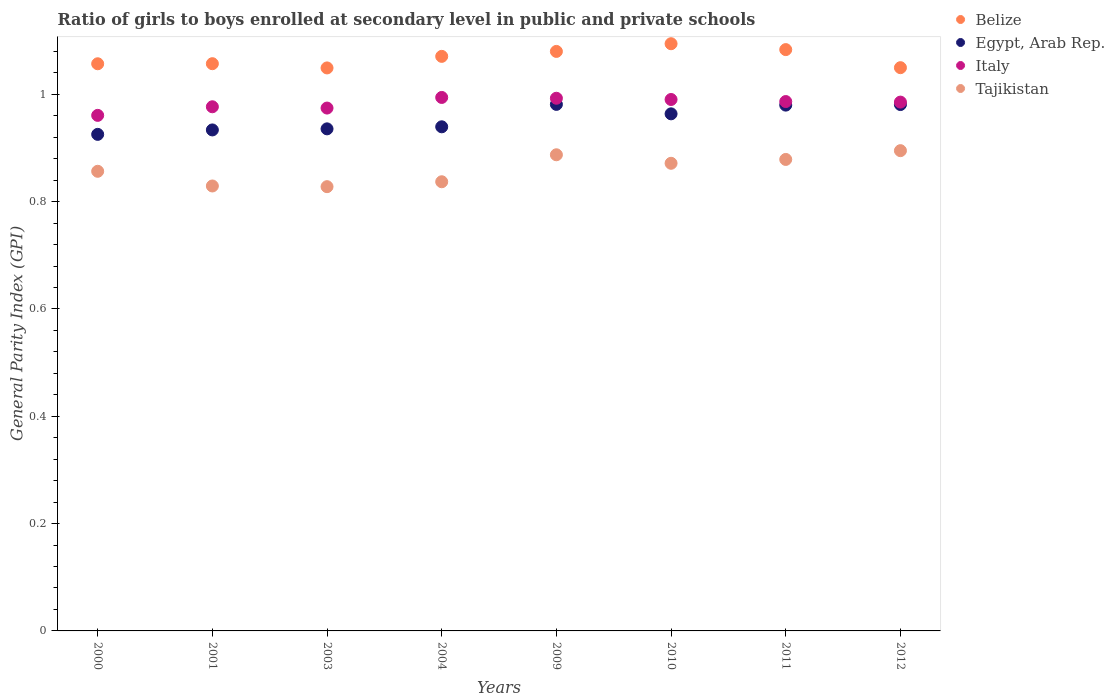Is the number of dotlines equal to the number of legend labels?
Provide a succinct answer. Yes. What is the general parity index in Italy in 2001?
Your answer should be compact. 0.98. Across all years, what is the maximum general parity index in Italy?
Ensure brevity in your answer.  0.99. Across all years, what is the minimum general parity index in Tajikistan?
Give a very brief answer. 0.83. In which year was the general parity index in Egypt, Arab Rep. maximum?
Provide a short and direct response. 2009. What is the total general parity index in Tajikistan in the graph?
Give a very brief answer. 6.88. What is the difference between the general parity index in Belize in 2011 and that in 2012?
Ensure brevity in your answer.  0.03. What is the difference between the general parity index in Egypt, Arab Rep. in 2011 and the general parity index in Tajikistan in 2003?
Offer a very short reply. 0.15. What is the average general parity index in Italy per year?
Your response must be concise. 0.98. In the year 2001, what is the difference between the general parity index in Tajikistan and general parity index in Egypt, Arab Rep.?
Give a very brief answer. -0.1. In how many years, is the general parity index in Tajikistan greater than 0.8?
Give a very brief answer. 8. What is the ratio of the general parity index in Tajikistan in 2009 to that in 2011?
Offer a very short reply. 1.01. What is the difference between the highest and the second highest general parity index in Tajikistan?
Offer a very short reply. 0.01. What is the difference between the highest and the lowest general parity index in Italy?
Make the answer very short. 0.03. In how many years, is the general parity index in Belize greater than the average general parity index in Belize taken over all years?
Offer a terse response. 4. Is the sum of the general parity index in Tajikistan in 2003 and 2012 greater than the maximum general parity index in Egypt, Arab Rep. across all years?
Keep it short and to the point. Yes. Is it the case that in every year, the sum of the general parity index in Tajikistan and general parity index in Italy  is greater than the general parity index in Belize?
Your answer should be compact. Yes. Does the general parity index in Egypt, Arab Rep. monotonically increase over the years?
Offer a very short reply. No. Is the general parity index in Tajikistan strictly greater than the general parity index in Egypt, Arab Rep. over the years?
Your response must be concise. No. How many dotlines are there?
Give a very brief answer. 4. How many years are there in the graph?
Ensure brevity in your answer.  8. What is the difference between two consecutive major ticks on the Y-axis?
Your answer should be compact. 0.2. Where does the legend appear in the graph?
Give a very brief answer. Top right. How are the legend labels stacked?
Your answer should be very brief. Vertical. What is the title of the graph?
Provide a succinct answer. Ratio of girls to boys enrolled at secondary level in public and private schools. Does "High income" appear as one of the legend labels in the graph?
Your answer should be very brief. No. What is the label or title of the Y-axis?
Offer a very short reply. General Parity Index (GPI). What is the General Parity Index (GPI) in Belize in 2000?
Your answer should be very brief. 1.06. What is the General Parity Index (GPI) of Egypt, Arab Rep. in 2000?
Provide a succinct answer. 0.93. What is the General Parity Index (GPI) of Italy in 2000?
Keep it short and to the point. 0.96. What is the General Parity Index (GPI) in Tajikistan in 2000?
Offer a terse response. 0.86. What is the General Parity Index (GPI) of Belize in 2001?
Offer a terse response. 1.06. What is the General Parity Index (GPI) of Egypt, Arab Rep. in 2001?
Provide a short and direct response. 0.93. What is the General Parity Index (GPI) in Italy in 2001?
Offer a terse response. 0.98. What is the General Parity Index (GPI) of Tajikistan in 2001?
Offer a very short reply. 0.83. What is the General Parity Index (GPI) of Belize in 2003?
Offer a very short reply. 1.05. What is the General Parity Index (GPI) in Egypt, Arab Rep. in 2003?
Provide a succinct answer. 0.94. What is the General Parity Index (GPI) of Italy in 2003?
Keep it short and to the point. 0.97. What is the General Parity Index (GPI) of Tajikistan in 2003?
Offer a very short reply. 0.83. What is the General Parity Index (GPI) of Belize in 2004?
Your answer should be compact. 1.07. What is the General Parity Index (GPI) in Egypt, Arab Rep. in 2004?
Make the answer very short. 0.94. What is the General Parity Index (GPI) in Italy in 2004?
Offer a terse response. 0.99. What is the General Parity Index (GPI) of Tajikistan in 2004?
Give a very brief answer. 0.84. What is the General Parity Index (GPI) of Belize in 2009?
Keep it short and to the point. 1.08. What is the General Parity Index (GPI) of Egypt, Arab Rep. in 2009?
Give a very brief answer. 0.98. What is the General Parity Index (GPI) of Italy in 2009?
Provide a succinct answer. 0.99. What is the General Parity Index (GPI) of Tajikistan in 2009?
Offer a very short reply. 0.89. What is the General Parity Index (GPI) of Belize in 2010?
Make the answer very short. 1.09. What is the General Parity Index (GPI) in Egypt, Arab Rep. in 2010?
Your answer should be compact. 0.96. What is the General Parity Index (GPI) in Italy in 2010?
Your answer should be very brief. 0.99. What is the General Parity Index (GPI) in Tajikistan in 2010?
Provide a succinct answer. 0.87. What is the General Parity Index (GPI) of Belize in 2011?
Keep it short and to the point. 1.08. What is the General Parity Index (GPI) in Egypt, Arab Rep. in 2011?
Offer a very short reply. 0.98. What is the General Parity Index (GPI) in Italy in 2011?
Your response must be concise. 0.99. What is the General Parity Index (GPI) in Tajikistan in 2011?
Your response must be concise. 0.88. What is the General Parity Index (GPI) in Belize in 2012?
Ensure brevity in your answer.  1.05. What is the General Parity Index (GPI) of Egypt, Arab Rep. in 2012?
Offer a very short reply. 0.98. What is the General Parity Index (GPI) of Italy in 2012?
Provide a short and direct response. 0.99. What is the General Parity Index (GPI) in Tajikistan in 2012?
Your answer should be compact. 0.9. Across all years, what is the maximum General Parity Index (GPI) in Belize?
Your answer should be very brief. 1.09. Across all years, what is the maximum General Parity Index (GPI) in Egypt, Arab Rep.?
Make the answer very short. 0.98. Across all years, what is the maximum General Parity Index (GPI) of Italy?
Keep it short and to the point. 0.99. Across all years, what is the maximum General Parity Index (GPI) of Tajikistan?
Offer a terse response. 0.9. Across all years, what is the minimum General Parity Index (GPI) in Belize?
Your answer should be very brief. 1.05. Across all years, what is the minimum General Parity Index (GPI) of Egypt, Arab Rep.?
Give a very brief answer. 0.93. Across all years, what is the minimum General Parity Index (GPI) in Italy?
Your answer should be compact. 0.96. Across all years, what is the minimum General Parity Index (GPI) of Tajikistan?
Keep it short and to the point. 0.83. What is the total General Parity Index (GPI) of Belize in the graph?
Your answer should be compact. 8.54. What is the total General Parity Index (GPI) in Egypt, Arab Rep. in the graph?
Offer a very short reply. 7.64. What is the total General Parity Index (GPI) of Italy in the graph?
Your answer should be very brief. 7.86. What is the total General Parity Index (GPI) in Tajikistan in the graph?
Ensure brevity in your answer.  6.88. What is the difference between the General Parity Index (GPI) of Belize in 2000 and that in 2001?
Make the answer very short. -0. What is the difference between the General Parity Index (GPI) of Egypt, Arab Rep. in 2000 and that in 2001?
Ensure brevity in your answer.  -0.01. What is the difference between the General Parity Index (GPI) of Italy in 2000 and that in 2001?
Provide a short and direct response. -0.02. What is the difference between the General Parity Index (GPI) of Tajikistan in 2000 and that in 2001?
Your answer should be very brief. 0.03. What is the difference between the General Parity Index (GPI) of Belize in 2000 and that in 2003?
Your answer should be very brief. 0.01. What is the difference between the General Parity Index (GPI) in Egypt, Arab Rep. in 2000 and that in 2003?
Ensure brevity in your answer.  -0.01. What is the difference between the General Parity Index (GPI) of Italy in 2000 and that in 2003?
Provide a succinct answer. -0.01. What is the difference between the General Parity Index (GPI) in Tajikistan in 2000 and that in 2003?
Ensure brevity in your answer.  0.03. What is the difference between the General Parity Index (GPI) of Belize in 2000 and that in 2004?
Your answer should be very brief. -0.01. What is the difference between the General Parity Index (GPI) of Egypt, Arab Rep. in 2000 and that in 2004?
Your answer should be compact. -0.01. What is the difference between the General Parity Index (GPI) of Italy in 2000 and that in 2004?
Offer a very short reply. -0.03. What is the difference between the General Parity Index (GPI) in Tajikistan in 2000 and that in 2004?
Give a very brief answer. 0.02. What is the difference between the General Parity Index (GPI) of Belize in 2000 and that in 2009?
Your answer should be very brief. -0.02. What is the difference between the General Parity Index (GPI) in Egypt, Arab Rep. in 2000 and that in 2009?
Give a very brief answer. -0.06. What is the difference between the General Parity Index (GPI) in Italy in 2000 and that in 2009?
Offer a terse response. -0.03. What is the difference between the General Parity Index (GPI) in Tajikistan in 2000 and that in 2009?
Offer a very short reply. -0.03. What is the difference between the General Parity Index (GPI) in Belize in 2000 and that in 2010?
Give a very brief answer. -0.04. What is the difference between the General Parity Index (GPI) in Egypt, Arab Rep. in 2000 and that in 2010?
Offer a very short reply. -0.04. What is the difference between the General Parity Index (GPI) in Italy in 2000 and that in 2010?
Give a very brief answer. -0.03. What is the difference between the General Parity Index (GPI) in Tajikistan in 2000 and that in 2010?
Provide a short and direct response. -0.01. What is the difference between the General Parity Index (GPI) of Belize in 2000 and that in 2011?
Offer a terse response. -0.03. What is the difference between the General Parity Index (GPI) in Egypt, Arab Rep. in 2000 and that in 2011?
Give a very brief answer. -0.05. What is the difference between the General Parity Index (GPI) of Italy in 2000 and that in 2011?
Provide a succinct answer. -0.03. What is the difference between the General Parity Index (GPI) in Tajikistan in 2000 and that in 2011?
Ensure brevity in your answer.  -0.02. What is the difference between the General Parity Index (GPI) in Belize in 2000 and that in 2012?
Keep it short and to the point. 0.01. What is the difference between the General Parity Index (GPI) in Egypt, Arab Rep. in 2000 and that in 2012?
Offer a very short reply. -0.06. What is the difference between the General Parity Index (GPI) of Italy in 2000 and that in 2012?
Your answer should be very brief. -0.02. What is the difference between the General Parity Index (GPI) of Tajikistan in 2000 and that in 2012?
Make the answer very short. -0.04. What is the difference between the General Parity Index (GPI) in Belize in 2001 and that in 2003?
Keep it short and to the point. 0.01. What is the difference between the General Parity Index (GPI) in Egypt, Arab Rep. in 2001 and that in 2003?
Your answer should be compact. -0. What is the difference between the General Parity Index (GPI) of Italy in 2001 and that in 2003?
Make the answer very short. 0. What is the difference between the General Parity Index (GPI) in Tajikistan in 2001 and that in 2003?
Ensure brevity in your answer.  0. What is the difference between the General Parity Index (GPI) of Belize in 2001 and that in 2004?
Keep it short and to the point. -0.01. What is the difference between the General Parity Index (GPI) in Egypt, Arab Rep. in 2001 and that in 2004?
Keep it short and to the point. -0.01. What is the difference between the General Parity Index (GPI) of Italy in 2001 and that in 2004?
Make the answer very short. -0.02. What is the difference between the General Parity Index (GPI) in Tajikistan in 2001 and that in 2004?
Your response must be concise. -0.01. What is the difference between the General Parity Index (GPI) in Belize in 2001 and that in 2009?
Offer a very short reply. -0.02. What is the difference between the General Parity Index (GPI) in Egypt, Arab Rep. in 2001 and that in 2009?
Your response must be concise. -0.05. What is the difference between the General Parity Index (GPI) of Italy in 2001 and that in 2009?
Ensure brevity in your answer.  -0.02. What is the difference between the General Parity Index (GPI) of Tajikistan in 2001 and that in 2009?
Provide a succinct answer. -0.06. What is the difference between the General Parity Index (GPI) of Belize in 2001 and that in 2010?
Your response must be concise. -0.04. What is the difference between the General Parity Index (GPI) in Egypt, Arab Rep. in 2001 and that in 2010?
Ensure brevity in your answer.  -0.03. What is the difference between the General Parity Index (GPI) in Italy in 2001 and that in 2010?
Ensure brevity in your answer.  -0.01. What is the difference between the General Parity Index (GPI) in Tajikistan in 2001 and that in 2010?
Your answer should be compact. -0.04. What is the difference between the General Parity Index (GPI) in Belize in 2001 and that in 2011?
Ensure brevity in your answer.  -0.03. What is the difference between the General Parity Index (GPI) in Egypt, Arab Rep. in 2001 and that in 2011?
Offer a very short reply. -0.05. What is the difference between the General Parity Index (GPI) in Italy in 2001 and that in 2011?
Your response must be concise. -0.01. What is the difference between the General Parity Index (GPI) in Tajikistan in 2001 and that in 2011?
Ensure brevity in your answer.  -0.05. What is the difference between the General Parity Index (GPI) in Belize in 2001 and that in 2012?
Your answer should be compact. 0.01. What is the difference between the General Parity Index (GPI) of Egypt, Arab Rep. in 2001 and that in 2012?
Give a very brief answer. -0.05. What is the difference between the General Parity Index (GPI) of Italy in 2001 and that in 2012?
Keep it short and to the point. -0.01. What is the difference between the General Parity Index (GPI) in Tajikistan in 2001 and that in 2012?
Your response must be concise. -0.07. What is the difference between the General Parity Index (GPI) in Belize in 2003 and that in 2004?
Ensure brevity in your answer.  -0.02. What is the difference between the General Parity Index (GPI) of Egypt, Arab Rep. in 2003 and that in 2004?
Offer a very short reply. -0. What is the difference between the General Parity Index (GPI) in Italy in 2003 and that in 2004?
Ensure brevity in your answer.  -0.02. What is the difference between the General Parity Index (GPI) of Tajikistan in 2003 and that in 2004?
Keep it short and to the point. -0.01. What is the difference between the General Parity Index (GPI) in Belize in 2003 and that in 2009?
Ensure brevity in your answer.  -0.03. What is the difference between the General Parity Index (GPI) in Egypt, Arab Rep. in 2003 and that in 2009?
Ensure brevity in your answer.  -0.05. What is the difference between the General Parity Index (GPI) of Italy in 2003 and that in 2009?
Ensure brevity in your answer.  -0.02. What is the difference between the General Parity Index (GPI) in Tajikistan in 2003 and that in 2009?
Your answer should be compact. -0.06. What is the difference between the General Parity Index (GPI) in Belize in 2003 and that in 2010?
Ensure brevity in your answer.  -0.05. What is the difference between the General Parity Index (GPI) of Egypt, Arab Rep. in 2003 and that in 2010?
Give a very brief answer. -0.03. What is the difference between the General Parity Index (GPI) in Italy in 2003 and that in 2010?
Keep it short and to the point. -0.02. What is the difference between the General Parity Index (GPI) in Tajikistan in 2003 and that in 2010?
Offer a terse response. -0.04. What is the difference between the General Parity Index (GPI) of Belize in 2003 and that in 2011?
Make the answer very short. -0.03. What is the difference between the General Parity Index (GPI) of Egypt, Arab Rep. in 2003 and that in 2011?
Offer a terse response. -0.04. What is the difference between the General Parity Index (GPI) of Italy in 2003 and that in 2011?
Your answer should be compact. -0.01. What is the difference between the General Parity Index (GPI) in Tajikistan in 2003 and that in 2011?
Your answer should be very brief. -0.05. What is the difference between the General Parity Index (GPI) in Belize in 2003 and that in 2012?
Your answer should be very brief. -0. What is the difference between the General Parity Index (GPI) in Egypt, Arab Rep. in 2003 and that in 2012?
Keep it short and to the point. -0.05. What is the difference between the General Parity Index (GPI) of Italy in 2003 and that in 2012?
Your answer should be compact. -0.01. What is the difference between the General Parity Index (GPI) of Tajikistan in 2003 and that in 2012?
Ensure brevity in your answer.  -0.07. What is the difference between the General Parity Index (GPI) of Belize in 2004 and that in 2009?
Offer a terse response. -0.01. What is the difference between the General Parity Index (GPI) in Egypt, Arab Rep. in 2004 and that in 2009?
Make the answer very short. -0.04. What is the difference between the General Parity Index (GPI) of Italy in 2004 and that in 2009?
Keep it short and to the point. 0. What is the difference between the General Parity Index (GPI) in Tajikistan in 2004 and that in 2009?
Make the answer very short. -0.05. What is the difference between the General Parity Index (GPI) of Belize in 2004 and that in 2010?
Provide a short and direct response. -0.02. What is the difference between the General Parity Index (GPI) in Egypt, Arab Rep. in 2004 and that in 2010?
Offer a very short reply. -0.02. What is the difference between the General Parity Index (GPI) in Italy in 2004 and that in 2010?
Keep it short and to the point. 0. What is the difference between the General Parity Index (GPI) of Tajikistan in 2004 and that in 2010?
Ensure brevity in your answer.  -0.03. What is the difference between the General Parity Index (GPI) of Belize in 2004 and that in 2011?
Give a very brief answer. -0.01. What is the difference between the General Parity Index (GPI) of Egypt, Arab Rep. in 2004 and that in 2011?
Your answer should be very brief. -0.04. What is the difference between the General Parity Index (GPI) in Italy in 2004 and that in 2011?
Provide a succinct answer. 0.01. What is the difference between the General Parity Index (GPI) in Tajikistan in 2004 and that in 2011?
Your response must be concise. -0.04. What is the difference between the General Parity Index (GPI) in Belize in 2004 and that in 2012?
Ensure brevity in your answer.  0.02. What is the difference between the General Parity Index (GPI) of Egypt, Arab Rep. in 2004 and that in 2012?
Provide a succinct answer. -0.04. What is the difference between the General Parity Index (GPI) in Italy in 2004 and that in 2012?
Give a very brief answer. 0.01. What is the difference between the General Parity Index (GPI) of Tajikistan in 2004 and that in 2012?
Keep it short and to the point. -0.06. What is the difference between the General Parity Index (GPI) in Belize in 2009 and that in 2010?
Make the answer very short. -0.01. What is the difference between the General Parity Index (GPI) in Egypt, Arab Rep. in 2009 and that in 2010?
Give a very brief answer. 0.02. What is the difference between the General Parity Index (GPI) of Italy in 2009 and that in 2010?
Provide a short and direct response. 0. What is the difference between the General Parity Index (GPI) of Tajikistan in 2009 and that in 2010?
Make the answer very short. 0.02. What is the difference between the General Parity Index (GPI) in Belize in 2009 and that in 2011?
Give a very brief answer. -0. What is the difference between the General Parity Index (GPI) in Egypt, Arab Rep. in 2009 and that in 2011?
Offer a very short reply. 0. What is the difference between the General Parity Index (GPI) of Italy in 2009 and that in 2011?
Offer a very short reply. 0.01. What is the difference between the General Parity Index (GPI) in Tajikistan in 2009 and that in 2011?
Offer a very short reply. 0.01. What is the difference between the General Parity Index (GPI) in Belize in 2009 and that in 2012?
Your answer should be compact. 0.03. What is the difference between the General Parity Index (GPI) in Egypt, Arab Rep. in 2009 and that in 2012?
Your answer should be very brief. 0. What is the difference between the General Parity Index (GPI) in Italy in 2009 and that in 2012?
Provide a short and direct response. 0.01. What is the difference between the General Parity Index (GPI) of Tajikistan in 2009 and that in 2012?
Make the answer very short. -0.01. What is the difference between the General Parity Index (GPI) in Belize in 2010 and that in 2011?
Offer a terse response. 0.01. What is the difference between the General Parity Index (GPI) in Egypt, Arab Rep. in 2010 and that in 2011?
Give a very brief answer. -0.02. What is the difference between the General Parity Index (GPI) in Italy in 2010 and that in 2011?
Make the answer very short. 0. What is the difference between the General Parity Index (GPI) in Tajikistan in 2010 and that in 2011?
Give a very brief answer. -0.01. What is the difference between the General Parity Index (GPI) in Belize in 2010 and that in 2012?
Ensure brevity in your answer.  0.04. What is the difference between the General Parity Index (GPI) in Egypt, Arab Rep. in 2010 and that in 2012?
Your answer should be compact. -0.02. What is the difference between the General Parity Index (GPI) in Italy in 2010 and that in 2012?
Keep it short and to the point. 0. What is the difference between the General Parity Index (GPI) of Tajikistan in 2010 and that in 2012?
Make the answer very short. -0.02. What is the difference between the General Parity Index (GPI) in Belize in 2011 and that in 2012?
Offer a terse response. 0.03. What is the difference between the General Parity Index (GPI) of Egypt, Arab Rep. in 2011 and that in 2012?
Your answer should be very brief. -0. What is the difference between the General Parity Index (GPI) in Tajikistan in 2011 and that in 2012?
Give a very brief answer. -0.02. What is the difference between the General Parity Index (GPI) of Belize in 2000 and the General Parity Index (GPI) of Egypt, Arab Rep. in 2001?
Keep it short and to the point. 0.12. What is the difference between the General Parity Index (GPI) in Belize in 2000 and the General Parity Index (GPI) in Italy in 2001?
Offer a terse response. 0.08. What is the difference between the General Parity Index (GPI) of Belize in 2000 and the General Parity Index (GPI) of Tajikistan in 2001?
Provide a short and direct response. 0.23. What is the difference between the General Parity Index (GPI) in Egypt, Arab Rep. in 2000 and the General Parity Index (GPI) in Italy in 2001?
Give a very brief answer. -0.05. What is the difference between the General Parity Index (GPI) in Egypt, Arab Rep. in 2000 and the General Parity Index (GPI) in Tajikistan in 2001?
Your response must be concise. 0.1. What is the difference between the General Parity Index (GPI) of Italy in 2000 and the General Parity Index (GPI) of Tajikistan in 2001?
Offer a very short reply. 0.13. What is the difference between the General Parity Index (GPI) of Belize in 2000 and the General Parity Index (GPI) of Egypt, Arab Rep. in 2003?
Provide a succinct answer. 0.12. What is the difference between the General Parity Index (GPI) of Belize in 2000 and the General Parity Index (GPI) of Italy in 2003?
Ensure brevity in your answer.  0.08. What is the difference between the General Parity Index (GPI) in Belize in 2000 and the General Parity Index (GPI) in Tajikistan in 2003?
Your answer should be very brief. 0.23. What is the difference between the General Parity Index (GPI) in Egypt, Arab Rep. in 2000 and the General Parity Index (GPI) in Italy in 2003?
Offer a very short reply. -0.05. What is the difference between the General Parity Index (GPI) in Egypt, Arab Rep. in 2000 and the General Parity Index (GPI) in Tajikistan in 2003?
Your response must be concise. 0.1. What is the difference between the General Parity Index (GPI) of Italy in 2000 and the General Parity Index (GPI) of Tajikistan in 2003?
Your answer should be very brief. 0.13. What is the difference between the General Parity Index (GPI) of Belize in 2000 and the General Parity Index (GPI) of Egypt, Arab Rep. in 2004?
Give a very brief answer. 0.12. What is the difference between the General Parity Index (GPI) in Belize in 2000 and the General Parity Index (GPI) in Italy in 2004?
Keep it short and to the point. 0.06. What is the difference between the General Parity Index (GPI) in Belize in 2000 and the General Parity Index (GPI) in Tajikistan in 2004?
Provide a short and direct response. 0.22. What is the difference between the General Parity Index (GPI) of Egypt, Arab Rep. in 2000 and the General Parity Index (GPI) of Italy in 2004?
Give a very brief answer. -0.07. What is the difference between the General Parity Index (GPI) in Egypt, Arab Rep. in 2000 and the General Parity Index (GPI) in Tajikistan in 2004?
Your response must be concise. 0.09. What is the difference between the General Parity Index (GPI) in Italy in 2000 and the General Parity Index (GPI) in Tajikistan in 2004?
Offer a very short reply. 0.12. What is the difference between the General Parity Index (GPI) of Belize in 2000 and the General Parity Index (GPI) of Egypt, Arab Rep. in 2009?
Provide a short and direct response. 0.08. What is the difference between the General Parity Index (GPI) of Belize in 2000 and the General Parity Index (GPI) of Italy in 2009?
Keep it short and to the point. 0.06. What is the difference between the General Parity Index (GPI) of Belize in 2000 and the General Parity Index (GPI) of Tajikistan in 2009?
Your answer should be very brief. 0.17. What is the difference between the General Parity Index (GPI) in Egypt, Arab Rep. in 2000 and the General Parity Index (GPI) in Italy in 2009?
Provide a succinct answer. -0.07. What is the difference between the General Parity Index (GPI) of Egypt, Arab Rep. in 2000 and the General Parity Index (GPI) of Tajikistan in 2009?
Provide a succinct answer. 0.04. What is the difference between the General Parity Index (GPI) of Italy in 2000 and the General Parity Index (GPI) of Tajikistan in 2009?
Keep it short and to the point. 0.07. What is the difference between the General Parity Index (GPI) of Belize in 2000 and the General Parity Index (GPI) of Egypt, Arab Rep. in 2010?
Provide a succinct answer. 0.09. What is the difference between the General Parity Index (GPI) of Belize in 2000 and the General Parity Index (GPI) of Italy in 2010?
Ensure brevity in your answer.  0.07. What is the difference between the General Parity Index (GPI) in Belize in 2000 and the General Parity Index (GPI) in Tajikistan in 2010?
Offer a terse response. 0.19. What is the difference between the General Parity Index (GPI) in Egypt, Arab Rep. in 2000 and the General Parity Index (GPI) in Italy in 2010?
Provide a succinct answer. -0.07. What is the difference between the General Parity Index (GPI) of Egypt, Arab Rep. in 2000 and the General Parity Index (GPI) of Tajikistan in 2010?
Provide a succinct answer. 0.05. What is the difference between the General Parity Index (GPI) in Italy in 2000 and the General Parity Index (GPI) in Tajikistan in 2010?
Provide a short and direct response. 0.09. What is the difference between the General Parity Index (GPI) in Belize in 2000 and the General Parity Index (GPI) in Egypt, Arab Rep. in 2011?
Make the answer very short. 0.08. What is the difference between the General Parity Index (GPI) of Belize in 2000 and the General Parity Index (GPI) of Italy in 2011?
Your answer should be very brief. 0.07. What is the difference between the General Parity Index (GPI) of Belize in 2000 and the General Parity Index (GPI) of Tajikistan in 2011?
Give a very brief answer. 0.18. What is the difference between the General Parity Index (GPI) of Egypt, Arab Rep. in 2000 and the General Parity Index (GPI) of Italy in 2011?
Make the answer very short. -0.06. What is the difference between the General Parity Index (GPI) in Egypt, Arab Rep. in 2000 and the General Parity Index (GPI) in Tajikistan in 2011?
Your response must be concise. 0.05. What is the difference between the General Parity Index (GPI) in Italy in 2000 and the General Parity Index (GPI) in Tajikistan in 2011?
Offer a terse response. 0.08. What is the difference between the General Parity Index (GPI) of Belize in 2000 and the General Parity Index (GPI) of Egypt, Arab Rep. in 2012?
Give a very brief answer. 0.08. What is the difference between the General Parity Index (GPI) in Belize in 2000 and the General Parity Index (GPI) in Italy in 2012?
Offer a terse response. 0.07. What is the difference between the General Parity Index (GPI) in Belize in 2000 and the General Parity Index (GPI) in Tajikistan in 2012?
Your response must be concise. 0.16. What is the difference between the General Parity Index (GPI) in Egypt, Arab Rep. in 2000 and the General Parity Index (GPI) in Italy in 2012?
Offer a very short reply. -0.06. What is the difference between the General Parity Index (GPI) in Egypt, Arab Rep. in 2000 and the General Parity Index (GPI) in Tajikistan in 2012?
Make the answer very short. 0.03. What is the difference between the General Parity Index (GPI) in Italy in 2000 and the General Parity Index (GPI) in Tajikistan in 2012?
Offer a very short reply. 0.07. What is the difference between the General Parity Index (GPI) in Belize in 2001 and the General Parity Index (GPI) in Egypt, Arab Rep. in 2003?
Ensure brevity in your answer.  0.12. What is the difference between the General Parity Index (GPI) of Belize in 2001 and the General Parity Index (GPI) of Italy in 2003?
Offer a very short reply. 0.08. What is the difference between the General Parity Index (GPI) of Belize in 2001 and the General Parity Index (GPI) of Tajikistan in 2003?
Ensure brevity in your answer.  0.23. What is the difference between the General Parity Index (GPI) of Egypt, Arab Rep. in 2001 and the General Parity Index (GPI) of Italy in 2003?
Offer a terse response. -0.04. What is the difference between the General Parity Index (GPI) of Egypt, Arab Rep. in 2001 and the General Parity Index (GPI) of Tajikistan in 2003?
Offer a very short reply. 0.11. What is the difference between the General Parity Index (GPI) of Italy in 2001 and the General Parity Index (GPI) of Tajikistan in 2003?
Ensure brevity in your answer.  0.15. What is the difference between the General Parity Index (GPI) of Belize in 2001 and the General Parity Index (GPI) of Egypt, Arab Rep. in 2004?
Provide a succinct answer. 0.12. What is the difference between the General Parity Index (GPI) of Belize in 2001 and the General Parity Index (GPI) of Italy in 2004?
Ensure brevity in your answer.  0.06. What is the difference between the General Parity Index (GPI) in Belize in 2001 and the General Parity Index (GPI) in Tajikistan in 2004?
Give a very brief answer. 0.22. What is the difference between the General Parity Index (GPI) of Egypt, Arab Rep. in 2001 and the General Parity Index (GPI) of Italy in 2004?
Offer a terse response. -0.06. What is the difference between the General Parity Index (GPI) in Egypt, Arab Rep. in 2001 and the General Parity Index (GPI) in Tajikistan in 2004?
Make the answer very short. 0.1. What is the difference between the General Parity Index (GPI) in Italy in 2001 and the General Parity Index (GPI) in Tajikistan in 2004?
Give a very brief answer. 0.14. What is the difference between the General Parity Index (GPI) in Belize in 2001 and the General Parity Index (GPI) in Egypt, Arab Rep. in 2009?
Your answer should be compact. 0.08. What is the difference between the General Parity Index (GPI) in Belize in 2001 and the General Parity Index (GPI) in Italy in 2009?
Offer a terse response. 0.06. What is the difference between the General Parity Index (GPI) of Belize in 2001 and the General Parity Index (GPI) of Tajikistan in 2009?
Keep it short and to the point. 0.17. What is the difference between the General Parity Index (GPI) of Egypt, Arab Rep. in 2001 and the General Parity Index (GPI) of Italy in 2009?
Your answer should be very brief. -0.06. What is the difference between the General Parity Index (GPI) in Egypt, Arab Rep. in 2001 and the General Parity Index (GPI) in Tajikistan in 2009?
Your response must be concise. 0.05. What is the difference between the General Parity Index (GPI) of Italy in 2001 and the General Parity Index (GPI) of Tajikistan in 2009?
Make the answer very short. 0.09. What is the difference between the General Parity Index (GPI) of Belize in 2001 and the General Parity Index (GPI) of Egypt, Arab Rep. in 2010?
Provide a short and direct response. 0.09. What is the difference between the General Parity Index (GPI) of Belize in 2001 and the General Parity Index (GPI) of Italy in 2010?
Make the answer very short. 0.07. What is the difference between the General Parity Index (GPI) in Belize in 2001 and the General Parity Index (GPI) in Tajikistan in 2010?
Give a very brief answer. 0.19. What is the difference between the General Parity Index (GPI) in Egypt, Arab Rep. in 2001 and the General Parity Index (GPI) in Italy in 2010?
Provide a succinct answer. -0.06. What is the difference between the General Parity Index (GPI) in Egypt, Arab Rep. in 2001 and the General Parity Index (GPI) in Tajikistan in 2010?
Provide a short and direct response. 0.06. What is the difference between the General Parity Index (GPI) of Italy in 2001 and the General Parity Index (GPI) of Tajikistan in 2010?
Provide a succinct answer. 0.11. What is the difference between the General Parity Index (GPI) in Belize in 2001 and the General Parity Index (GPI) in Egypt, Arab Rep. in 2011?
Your answer should be compact. 0.08. What is the difference between the General Parity Index (GPI) of Belize in 2001 and the General Parity Index (GPI) of Italy in 2011?
Your answer should be compact. 0.07. What is the difference between the General Parity Index (GPI) of Belize in 2001 and the General Parity Index (GPI) of Tajikistan in 2011?
Your answer should be very brief. 0.18. What is the difference between the General Parity Index (GPI) in Egypt, Arab Rep. in 2001 and the General Parity Index (GPI) in Italy in 2011?
Your response must be concise. -0.05. What is the difference between the General Parity Index (GPI) in Egypt, Arab Rep. in 2001 and the General Parity Index (GPI) in Tajikistan in 2011?
Keep it short and to the point. 0.06. What is the difference between the General Parity Index (GPI) of Italy in 2001 and the General Parity Index (GPI) of Tajikistan in 2011?
Provide a short and direct response. 0.1. What is the difference between the General Parity Index (GPI) in Belize in 2001 and the General Parity Index (GPI) in Egypt, Arab Rep. in 2012?
Keep it short and to the point. 0.08. What is the difference between the General Parity Index (GPI) in Belize in 2001 and the General Parity Index (GPI) in Italy in 2012?
Ensure brevity in your answer.  0.07. What is the difference between the General Parity Index (GPI) in Belize in 2001 and the General Parity Index (GPI) in Tajikistan in 2012?
Your answer should be compact. 0.16. What is the difference between the General Parity Index (GPI) in Egypt, Arab Rep. in 2001 and the General Parity Index (GPI) in Italy in 2012?
Your answer should be very brief. -0.05. What is the difference between the General Parity Index (GPI) of Egypt, Arab Rep. in 2001 and the General Parity Index (GPI) of Tajikistan in 2012?
Your response must be concise. 0.04. What is the difference between the General Parity Index (GPI) of Italy in 2001 and the General Parity Index (GPI) of Tajikistan in 2012?
Your answer should be compact. 0.08. What is the difference between the General Parity Index (GPI) in Belize in 2003 and the General Parity Index (GPI) in Egypt, Arab Rep. in 2004?
Offer a very short reply. 0.11. What is the difference between the General Parity Index (GPI) of Belize in 2003 and the General Parity Index (GPI) of Italy in 2004?
Make the answer very short. 0.06. What is the difference between the General Parity Index (GPI) of Belize in 2003 and the General Parity Index (GPI) of Tajikistan in 2004?
Ensure brevity in your answer.  0.21. What is the difference between the General Parity Index (GPI) of Egypt, Arab Rep. in 2003 and the General Parity Index (GPI) of Italy in 2004?
Provide a short and direct response. -0.06. What is the difference between the General Parity Index (GPI) in Egypt, Arab Rep. in 2003 and the General Parity Index (GPI) in Tajikistan in 2004?
Offer a very short reply. 0.1. What is the difference between the General Parity Index (GPI) of Italy in 2003 and the General Parity Index (GPI) of Tajikistan in 2004?
Offer a terse response. 0.14. What is the difference between the General Parity Index (GPI) of Belize in 2003 and the General Parity Index (GPI) of Egypt, Arab Rep. in 2009?
Your response must be concise. 0.07. What is the difference between the General Parity Index (GPI) of Belize in 2003 and the General Parity Index (GPI) of Italy in 2009?
Provide a short and direct response. 0.06. What is the difference between the General Parity Index (GPI) in Belize in 2003 and the General Parity Index (GPI) in Tajikistan in 2009?
Offer a terse response. 0.16. What is the difference between the General Parity Index (GPI) of Egypt, Arab Rep. in 2003 and the General Parity Index (GPI) of Italy in 2009?
Offer a terse response. -0.06. What is the difference between the General Parity Index (GPI) of Egypt, Arab Rep. in 2003 and the General Parity Index (GPI) of Tajikistan in 2009?
Give a very brief answer. 0.05. What is the difference between the General Parity Index (GPI) in Italy in 2003 and the General Parity Index (GPI) in Tajikistan in 2009?
Offer a terse response. 0.09. What is the difference between the General Parity Index (GPI) of Belize in 2003 and the General Parity Index (GPI) of Egypt, Arab Rep. in 2010?
Your response must be concise. 0.09. What is the difference between the General Parity Index (GPI) of Belize in 2003 and the General Parity Index (GPI) of Italy in 2010?
Your response must be concise. 0.06. What is the difference between the General Parity Index (GPI) in Belize in 2003 and the General Parity Index (GPI) in Tajikistan in 2010?
Keep it short and to the point. 0.18. What is the difference between the General Parity Index (GPI) of Egypt, Arab Rep. in 2003 and the General Parity Index (GPI) of Italy in 2010?
Give a very brief answer. -0.05. What is the difference between the General Parity Index (GPI) in Egypt, Arab Rep. in 2003 and the General Parity Index (GPI) in Tajikistan in 2010?
Provide a succinct answer. 0.06. What is the difference between the General Parity Index (GPI) in Italy in 2003 and the General Parity Index (GPI) in Tajikistan in 2010?
Provide a short and direct response. 0.1. What is the difference between the General Parity Index (GPI) of Belize in 2003 and the General Parity Index (GPI) of Egypt, Arab Rep. in 2011?
Make the answer very short. 0.07. What is the difference between the General Parity Index (GPI) of Belize in 2003 and the General Parity Index (GPI) of Italy in 2011?
Your answer should be compact. 0.06. What is the difference between the General Parity Index (GPI) of Belize in 2003 and the General Parity Index (GPI) of Tajikistan in 2011?
Ensure brevity in your answer.  0.17. What is the difference between the General Parity Index (GPI) of Egypt, Arab Rep. in 2003 and the General Parity Index (GPI) of Italy in 2011?
Give a very brief answer. -0.05. What is the difference between the General Parity Index (GPI) of Egypt, Arab Rep. in 2003 and the General Parity Index (GPI) of Tajikistan in 2011?
Keep it short and to the point. 0.06. What is the difference between the General Parity Index (GPI) in Italy in 2003 and the General Parity Index (GPI) in Tajikistan in 2011?
Your response must be concise. 0.1. What is the difference between the General Parity Index (GPI) of Belize in 2003 and the General Parity Index (GPI) of Egypt, Arab Rep. in 2012?
Offer a very short reply. 0.07. What is the difference between the General Parity Index (GPI) in Belize in 2003 and the General Parity Index (GPI) in Italy in 2012?
Your answer should be very brief. 0.06. What is the difference between the General Parity Index (GPI) of Belize in 2003 and the General Parity Index (GPI) of Tajikistan in 2012?
Provide a succinct answer. 0.15. What is the difference between the General Parity Index (GPI) of Egypt, Arab Rep. in 2003 and the General Parity Index (GPI) of Italy in 2012?
Give a very brief answer. -0.05. What is the difference between the General Parity Index (GPI) of Egypt, Arab Rep. in 2003 and the General Parity Index (GPI) of Tajikistan in 2012?
Make the answer very short. 0.04. What is the difference between the General Parity Index (GPI) of Italy in 2003 and the General Parity Index (GPI) of Tajikistan in 2012?
Give a very brief answer. 0.08. What is the difference between the General Parity Index (GPI) in Belize in 2004 and the General Parity Index (GPI) in Egypt, Arab Rep. in 2009?
Your answer should be very brief. 0.09. What is the difference between the General Parity Index (GPI) in Belize in 2004 and the General Parity Index (GPI) in Italy in 2009?
Keep it short and to the point. 0.08. What is the difference between the General Parity Index (GPI) in Belize in 2004 and the General Parity Index (GPI) in Tajikistan in 2009?
Offer a very short reply. 0.18. What is the difference between the General Parity Index (GPI) in Egypt, Arab Rep. in 2004 and the General Parity Index (GPI) in Italy in 2009?
Keep it short and to the point. -0.05. What is the difference between the General Parity Index (GPI) in Egypt, Arab Rep. in 2004 and the General Parity Index (GPI) in Tajikistan in 2009?
Your answer should be compact. 0.05. What is the difference between the General Parity Index (GPI) in Italy in 2004 and the General Parity Index (GPI) in Tajikistan in 2009?
Make the answer very short. 0.11. What is the difference between the General Parity Index (GPI) in Belize in 2004 and the General Parity Index (GPI) in Egypt, Arab Rep. in 2010?
Offer a terse response. 0.11. What is the difference between the General Parity Index (GPI) in Belize in 2004 and the General Parity Index (GPI) in Italy in 2010?
Make the answer very short. 0.08. What is the difference between the General Parity Index (GPI) of Belize in 2004 and the General Parity Index (GPI) of Tajikistan in 2010?
Make the answer very short. 0.2. What is the difference between the General Parity Index (GPI) of Egypt, Arab Rep. in 2004 and the General Parity Index (GPI) of Italy in 2010?
Offer a very short reply. -0.05. What is the difference between the General Parity Index (GPI) of Egypt, Arab Rep. in 2004 and the General Parity Index (GPI) of Tajikistan in 2010?
Offer a terse response. 0.07. What is the difference between the General Parity Index (GPI) of Italy in 2004 and the General Parity Index (GPI) of Tajikistan in 2010?
Offer a very short reply. 0.12. What is the difference between the General Parity Index (GPI) of Belize in 2004 and the General Parity Index (GPI) of Egypt, Arab Rep. in 2011?
Give a very brief answer. 0.09. What is the difference between the General Parity Index (GPI) of Belize in 2004 and the General Parity Index (GPI) of Italy in 2011?
Offer a very short reply. 0.08. What is the difference between the General Parity Index (GPI) in Belize in 2004 and the General Parity Index (GPI) in Tajikistan in 2011?
Offer a very short reply. 0.19. What is the difference between the General Parity Index (GPI) of Egypt, Arab Rep. in 2004 and the General Parity Index (GPI) of Italy in 2011?
Keep it short and to the point. -0.05. What is the difference between the General Parity Index (GPI) in Egypt, Arab Rep. in 2004 and the General Parity Index (GPI) in Tajikistan in 2011?
Your response must be concise. 0.06. What is the difference between the General Parity Index (GPI) in Italy in 2004 and the General Parity Index (GPI) in Tajikistan in 2011?
Provide a succinct answer. 0.12. What is the difference between the General Parity Index (GPI) in Belize in 2004 and the General Parity Index (GPI) in Egypt, Arab Rep. in 2012?
Offer a terse response. 0.09. What is the difference between the General Parity Index (GPI) in Belize in 2004 and the General Parity Index (GPI) in Italy in 2012?
Your answer should be compact. 0.09. What is the difference between the General Parity Index (GPI) of Belize in 2004 and the General Parity Index (GPI) of Tajikistan in 2012?
Your answer should be very brief. 0.18. What is the difference between the General Parity Index (GPI) in Egypt, Arab Rep. in 2004 and the General Parity Index (GPI) in Italy in 2012?
Your answer should be very brief. -0.05. What is the difference between the General Parity Index (GPI) of Egypt, Arab Rep. in 2004 and the General Parity Index (GPI) of Tajikistan in 2012?
Your answer should be compact. 0.04. What is the difference between the General Parity Index (GPI) of Italy in 2004 and the General Parity Index (GPI) of Tajikistan in 2012?
Make the answer very short. 0.1. What is the difference between the General Parity Index (GPI) of Belize in 2009 and the General Parity Index (GPI) of Egypt, Arab Rep. in 2010?
Ensure brevity in your answer.  0.12. What is the difference between the General Parity Index (GPI) in Belize in 2009 and the General Parity Index (GPI) in Italy in 2010?
Your answer should be very brief. 0.09. What is the difference between the General Parity Index (GPI) of Belize in 2009 and the General Parity Index (GPI) of Tajikistan in 2010?
Give a very brief answer. 0.21. What is the difference between the General Parity Index (GPI) in Egypt, Arab Rep. in 2009 and the General Parity Index (GPI) in Italy in 2010?
Offer a terse response. -0.01. What is the difference between the General Parity Index (GPI) in Egypt, Arab Rep. in 2009 and the General Parity Index (GPI) in Tajikistan in 2010?
Give a very brief answer. 0.11. What is the difference between the General Parity Index (GPI) in Italy in 2009 and the General Parity Index (GPI) in Tajikistan in 2010?
Keep it short and to the point. 0.12. What is the difference between the General Parity Index (GPI) of Belize in 2009 and the General Parity Index (GPI) of Egypt, Arab Rep. in 2011?
Make the answer very short. 0.1. What is the difference between the General Parity Index (GPI) in Belize in 2009 and the General Parity Index (GPI) in Italy in 2011?
Your answer should be compact. 0.09. What is the difference between the General Parity Index (GPI) in Belize in 2009 and the General Parity Index (GPI) in Tajikistan in 2011?
Make the answer very short. 0.2. What is the difference between the General Parity Index (GPI) of Egypt, Arab Rep. in 2009 and the General Parity Index (GPI) of Italy in 2011?
Your answer should be compact. -0.01. What is the difference between the General Parity Index (GPI) of Egypt, Arab Rep. in 2009 and the General Parity Index (GPI) of Tajikistan in 2011?
Provide a short and direct response. 0.1. What is the difference between the General Parity Index (GPI) in Italy in 2009 and the General Parity Index (GPI) in Tajikistan in 2011?
Provide a succinct answer. 0.11. What is the difference between the General Parity Index (GPI) of Belize in 2009 and the General Parity Index (GPI) of Egypt, Arab Rep. in 2012?
Ensure brevity in your answer.  0.1. What is the difference between the General Parity Index (GPI) in Belize in 2009 and the General Parity Index (GPI) in Italy in 2012?
Offer a very short reply. 0.09. What is the difference between the General Parity Index (GPI) of Belize in 2009 and the General Parity Index (GPI) of Tajikistan in 2012?
Offer a terse response. 0.18. What is the difference between the General Parity Index (GPI) of Egypt, Arab Rep. in 2009 and the General Parity Index (GPI) of Italy in 2012?
Provide a succinct answer. -0. What is the difference between the General Parity Index (GPI) in Egypt, Arab Rep. in 2009 and the General Parity Index (GPI) in Tajikistan in 2012?
Offer a very short reply. 0.09. What is the difference between the General Parity Index (GPI) of Italy in 2009 and the General Parity Index (GPI) of Tajikistan in 2012?
Offer a terse response. 0.1. What is the difference between the General Parity Index (GPI) of Belize in 2010 and the General Parity Index (GPI) of Egypt, Arab Rep. in 2011?
Offer a terse response. 0.11. What is the difference between the General Parity Index (GPI) in Belize in 2010 and the General Parity Index (GPI) in Italy in 2011?
Keep it short and to the point. 0.11. What is the difference between the General Parity Index (GPI) in Belize in 2010 and the General Parity Index (GPI) in Tajikistan in 2011?
Offer a terse response. 0.22. What is the difference between the General Parity Index (GPI) of Egypt, Arab Rep. in 2010 and the General Parity Index (GPI) of Italy in 2011?
Give a very brief answer. -0.02. What is the difference between the General Parity Index (GPI) of Egypt, Arab Rep. in 2010 and the General Parity Index (GPI) of Tajikistan in 2011?
Keep it short and to the point. 0.09. What is the difference between the General Parity Index (GPI) of Italy in 2010 and the General Parity Index (GPI) of Tajikistan in 2011?
Offer a very short reply. 0.11. What is the difference between the General Parity Index (GPI) of Belize in 2010 and the General Parity Index (GPI) of Egypt, Arab Rep. in 2012?
Provide a short and direct response. 0.11. What is the difference between the General Parity Index (GPI) in Belize in 2010 and the General Parity Index (GPI) in Italy in 2012?
Offer a terse response. 0.11. What is the difference between the General Parity Index (GPI) of Belize in 2010 and the General Parity Index (GPI) of Tajikistan in 2012?
Provide a short and direct response. 0.2. What is the difference between the General Parity Index (GPI) in Egypt, Arab Rep. in 2010 and the General Parity Index (GPI) in Italy in 2012?
Make the answer very short. -0.02. What is the difference between the General Parity Index (GPI) of Egypt, Arab Rep. in 2010 and the General Parity Index (GPI) of Tajikistan in 2012?
Give a very brief answer. 0.07. What is the difference between the General Parity Index (GPI) in Italy in 2010 and the General Parity Index (GPI) in Tajikistan in 2012?
Ensure brevity in your answer.  0.1. What is the difference between the General Parity Index (GPI) in Belize in 2011 and the General Parity Index (GPI) in Egypt, Arab Rep. in 2012?
Provide a short and direct response. 0.1. What is the difference between the General Parity Index (GPI) in Belize in 2011 and the General Parity Index (GPI) in Italy in 2012?
Your response must be concise. 0.1. What is the difference between the General Parity Index (GPI) in Belize in 2011 and the General Parity Index (GPI) in Tajikistan in 2012?
Provide a succinct answer. 0.19. What is the difference between the General Parity Index (GPI) in Egypt, Arab Rep. in 2011 and the General Parity Index (GPI) in Italy in 2012?
Provide a succinct answer. -0.01. What is the difference between the General Parity Index (GPI) of Egypt, Arab Rep. in 2011 and the General Parity Index (GPI) of Tajikistan in 2012?
Make the answer very short. 0.08. What is the difference between the General Parity Index (GPI) of Italy in 2011 and the General Parity Index (GPI) of Tajikistan in 2012?
Provide a succinct answer. 0.09. What is the average General Parity Index (GPI) in Belize per year?
Make the answer very short. 1.07. What is the average General Parity Index (GPI) of Egypt, Arab Rep. per year?
Offer a very short reply. 0.96. What is the average General Parity Index (GPI) in Italy per year?
Your answer should be compact. 0.98. What is the average General Parity Index (GPI) in Tajikistan per year?
Provide a short and direct response. 0.86. In the year 2000, what is the difference between the General Parity Index (GPI) of Belize and General Parity Index (GPI) of Egypt, Arab Rep.?
Provide a short and direct response. 0.13. In the year 2000, what is the difference between the General Parity Index (GPI) of Belize and General Parity Index (GPI) of Italy?
Your answer should be compact. 0.1. In the year 2000, what is the difference between the General Parity Index (GPI) of Belize and General Parity Index (GPI) of Tajikistan?
Provide a succinct answer. 0.2. In the year 2000, what is the difference between the General Parity Index (GPI) in Egypt, Arab Rep. and General Parity Index (GPI) in Italy?
Make the answer very short. -0.04. In the year 2000, what is the difference between the General Parity Index (GPI) in Egypt, Arab Rep. and General Parity Index (GPI) in Tajikistan?
Your response must be concise. 0.07. In the year 2000, what is the difference between the General Parity Index (GPI) of Italy and General Parity Index (GPI) of Tajikistan?
Your response must be concise. 0.1. In the year 2001, what is the difference between the General Parity Index (GPI) of Belize and General Parity Index (GPI) of Egypt, Arab Rep.?
Provide a short and direct response. 0.12. In the year 2001, what is the difference between the General Parity Index (GPI) of Belize and General Parity Index (GPI) of Italy?
Offer a terse response. 0.08. In the year 2001, what is the difference between the General Parity Index (GPI) in Belize and General Parity Index (GPI) in Tajikistan?
Make the answer very short. 0.23. In the year 2001, what is the difference between the General Parity Index (GPI) in Egypt, Arab Rep. and General Parity Index (GPI) in Italy?
Provide a short and direct response. -0.04. In the year 2001, what is the difference between the General Parity Index (GPI) of Egypt, Arab Rep. and General Parity Index (GPI) of Tajikistan?
Keep it short and to the point. 0.1. In the year 2001, what is the difference between the General Parity Index (GPI) of Italy and General Parity Index (GPI) of Tajikistan?
Ensure brevity in your answer.  0.15. In the year 2003, what is the difference between the General Parity Index (GPI) in Belize and General Parity Index (GPI) in Egypt, Arab Rep.?
Keep it short and to the point. 0.11. In the year 2003, what is the difference between the General Parity Index (GPI) of Belize and General Parity Index (GPI) of Italy?
Keep it short and to the point. 0.07. In the year 2003, what is the difference between the General Parity Index (GPI) of Belize and General Parity Index (GPI) of Tajikistan?
Offer a very short reply. 0.22. In the year 2003, what is the difference between the General Parity Index (GPI) in Egypt, Arab Rep. and General Parity Index (GPI) in Italy?
Make the answer very short. -0.04. In the year 2003, what is the difference between the General Parity Index (GPI) of Egypt, Arab Rep. and General Parity Index (GPI) of Tajikistan?
Provide a short and direct response. 0.11. In the year 2003, what is the difference between the General Parity Index (GPI) in Italy and General Parity Index (GPI) in Tajikistan?
Your answer should be very brief. 0.15. In the year 2004, what is the difference between the General Parity Index (GPI) in Belize and General Parity Index (GPI) in Egypt, Arab Rep.?
Your response must be concise. 0.13. In the year 2004, what is the difference between the General Parity Index (GPI) of Belize and General Parity Index (GPI) of Italy?
Offer a terse response. 0.08. In the year 2004, what is the difference between the General Parity Index (GPI) of Belize and General Parity Index (GPI) of Tajikistan?
Offer a very short reply. 0.23. In the year 2004, what is the difference between the General Parity Index (GPI) of Egypt, Arab Rep. and General Parity Index (GPI) of Italy?
Offer a very short reply. -0.05. In the year 2004, what is the difference between the General Parity Index (GPI) in Egypt, Arab Rep. and General Parity Index (GPI) in Tajikistan?
Provide a succinct answer. 0.1. In the year 2004, what is the difference between the General Parity Index (GPI) of Italy and General Parity Index (GPI) of Tajikistan?
Make the answer very short. 0.16. In the year 2009, what is the difference between the General Parity Index (GPI) in Belize and General Parity Index (GPI) in Egypt, Arab Rep.?
Make the answer very short. 0.1. In the year 2009, what is the difference between the General Parity Index (GPI) in Belize and General Parity Index (GPI) in Italy?
Provide a short and direct response. 0.09. In the year 2009, what is the difference between the General Parity Index (GPI) of Belize and General Parity Index (GPI) of Tajikistan?
Provide a succinct answer. 0.19. In the year 2009, what is the difference between the General Parity Index (GPI) of Egypt, Arab Rep. and General Parity Index (GPI) of Italy?
Your response must be concise. -0.01. In the year 2009, what is the difference between the General Parity Index (GPI) of Egypt, Arab Rep. and General Parity Index (GPI) of Tajikistan?
Give a very brief answer. 0.09. In the year 2009, what is the difference between the General Parity Index (GPI) of Italy and General Parity Index (GPI) of Tajikistan?
Keep it short and to the point. 0.11. In the year 2010, what is the difference between the General Parity Index (GPI) of Belize and General Parity Index (GPI) of Egypt, Arab Rep.?
Give a very brief answer. 0.13. In the year 2010, what is the difference between the General Parity Index (GPI) of Belize and General Parity Index (GPI) of Italy?
Offer a very short reply. 0.1. In the year 2010, what is the difference between the General Parity Index (GPI) in Belize and General Parity Index (GPI) in Tajikistan?
Keep it short and to the point. 0.22. In the year 2010, what is the difference between the General Parity Index (GPI) in Egypt, Arab Rep. and General Parity Index (GPI) in Italy?
Provide a short and direct response. -0.03. In the year 2010, what is the difference between the General Parity Index (GPI) in Egypt, Arab Rep. and General Parity Index (GPI) in Tajikistan?
Provide a short and direct response. 0.09. In the year 2010, what is the difference between the General Parity Index (GPI) in Italy and General Parity Index (GPI) in Tajikistan?
Ensure brevity in your answer.  0.12. In the year 2011, what is the difference between the General Parity Index (GPI) in Belize and General Parity Index (GPI) in Egypt, Arab Rep.?
Make the answer very short. 0.1. In the year 2011, what is the difference between the General Parity Index (GPI) of Belize and General Parity Index (GPI) of Italy?
Your response must be concise. 0.1. In the year 2011, what is the difference between the General Parity Index (GPI) in Belize and General Parity Index (GPI) in Tajikistan?
Your response must be concise. 0.2. In the year 2011, what is the difference between the General Parity Index (GPI) in Egypt, Arab Rep. and General Parity Index (GPI) in Italy?
Your answer should be compact. -0.01. In the year 2011, what is the difference between the General Parity Index (GPI) of Egypt, Arab Rep. and General Parity Index (GPI) of Tajikistan?
Offer a very short reply. 0.1. In the year 2011, what is the difference between the General Parity Index (GPI) of Italy and General Parity Index (GPI) of Tajikistan?
Provide a short and direct response. 0.11. In the year 2012, what is the difference between the General Parity Index (GPI) in Belize and General Parity Index (GPI) in Egypt, Arab Rep.?
Offer a very short reply. 0.07. In the year 2012, what is the difference between the General Parity Index (GPI) in Belize and General Parity Index (GPI) in Italy?
Keep it short and to the point. 0.06. In the year 2012, what is the difference between the General Parity Index (GPI) in Belize and General Parity Index (GPI) in Tajikistan?
Your response must be concise. 0.15. In the year 2012, what is the difference between the General Parity Index (GPI) of Egypt, Arab Rep. and General Parity Index (GPI) of Italy?
Offer a very short reply. -0. In the year 2012, what is the difference between the General Parity Index (GPI) of Egypt, Arab Rep. and General Parity Index (GPI) of Tajikistan?
Provide a succinct answer. 0.09. In the year 2012, what is the difference between the General Parity Index (GPI) of Italy and General Parity Index (GPI) of Tajikistan?
Keep it short and to the point. 0.09. What is the ratio of the General Parity Index (GPI) in Italy in 2000 to that in 2001?
Provide a succinct answer. 0.98. What is the ratio of the General Parity Index (GPI) of Tajikistan in 2000 to that in 2001?
Offer a terse response. 1.03. What is the ratio of the General Parity Index (GPI) of Belize in 2000 to that in 2003?
Provide a short and direct response. 1.01. What is the ratio of the General Parity Index (GPI) of Egypt, Arab Rep. in 2000 to that in 2003?
Ensure brevity in your answer.  0.99. What is the ratio of the General Parity Index (GPI) in Tajikistan in 2000 to that in 2003?
Your answer should be very brief. 1.03. What is the ratio of the General Parity Index (GPI) in Belize in 2000 to that in 2004?
Offer a very short reply. 0.99. What is the ratio of the General Parity Index (GPI) of Egypt, Arab Rep. in 2000 to that in 2004?
Your response must be concise. 0.98. What is the ratio of the General Parity Index (GPI) in Italy in 2000 to that in 2004?
Ensure brevity in your answer.  0.97. What is the ratio of the General Parity Index (GPI) of Tajikistan in 2000 to that in 2004?
Provide a short and direct response. 1.02. What is the ratio of the General Parity Index (GPI) in Belize in 2000 to that in 2009?
Your response must be concise. 0.98. What is the ratio of the General Parity Index (GPI) of Egypt, Arab Rep. in 2000 to that in 2009?
Offer a terse response. 0.94. What is the ratio of the General Parity Index (GPI) of Italy in 2000 to that in 2009?
Offer a very short reply. 0.97. What is the ratio of the General Parity Index (GPI) in Tajikistan in 2000 to that in 2009?
Offer a very short reply. 0.97. What is the ratio of the General Parity Index (GPI) of Belize in 2000 to that in 2010?
Keep it short and to the point. 0.97. What is the ratio of the General Parity Index (GPI) in Egypt, Arab Rep. in 2000 to that in 2010?
Offer a very short reply. 0.96. What is the ratio of the General Parity Index (GPI) in Italy in 2000 to that in 2010?
Give a very brief answer. 0.97. What is the ratio of the General Parity Index (GPI) of Tajikistan in 2000 to that in 2010?
Your response must be concise. 0.98. What is the ratio of the General Parity Index (GPI) in Belize in 2000 to that in 2011?
Make the answer very short. 0.98. What is the ratio of the General Parity Index (GPI) of Egypt, Arab Rep. in 2000 to that in 2011?
Give a very brief answer. 0.94. What is the ratio of the General Parity Index (GPI) in Italy in 2000 to that in 2011?
Offer a terse response. 0.97. What is the ratio of the General Parity Index (GPI) in Tajikistan in 2000 to that in 2011?
Make the answer very short. 0.97. What is the ratio of the General Parity Index (GPI) in Egypt, Arab Rep. in 2000 to that in 2012?
Give a very brief answer. 0.94. What is the ratio of the General Parity Index (GPI) in Italy in 2000 to that in 2012?
Provide a succinct answer. 0.97. What is the ratio of the General Parity Index (GPI) of Tajikistan in 2000 to that in 2012?
Give a very brief answer. 0.96. What is the ratio of the General Parity Index (GPI) in Belize in 2001 to that in 2003?
Offer a terse response. 1.01. What is the ratio of the General Parity Index (GPI) of Belize in 2001 to that in 2004?
Offer a very short reply. 0.99. What is the ratio of the General Parity Index (GPI) in Italy in 2001 to that in 2004?
Ensure brevity in your answer.  0.98. What is the ratio of the General Parity Index (GPI) in Tajikistan in 2001 to that in 2004?
Offer a terse response. 0.99. What is the ratio of the General Parity Index (GPI) of Belize in 2001 to that in 2009?
Provide a short and direct response. 0.98. What is the ratio of the General Parity Index (GPI) in Egypt, Arab Rep. in 2001 to that in 2009?
Ensure brevity in your answer.  0.95. What is the ratio of the General Parity Index (GPI) in Tajikistan in 2001 to that in 2009?
Offer a terse response. 0.93. What is the ratio of the General Parity Index (GPI) in Egypt, Arab Rep. in 2001 to that in 2010?
Give a very brief answer. 0.97. What is the ratio of the General Parity Index (GPI) in Italy in 2001 to that in 2010?
Make the answer very short. 0.99. What is the ratio of the General Parity Index (GPI) in Tajikistan in 2001 to that in 2010?
Make the answer very short. 0.95. What is the ratio of the General Parity Index (GPI) of Belize in 2001 to that in 2011?
Your answer should be very brief. 0.98. What is the ratio of the General Parity Index (GPI) in Egypt, Arab Rep. in 2001 to that in 2011?
Your answer should be compact. 0.95. What is the ratio of the General Parity Index (GPI) in Tajikistan in 2001 to that in 2011?
Your answer should be compact. 0.94. What is the ratio of the General Parity Index (GPI) in Belize in 2001 to that in 2012?
Offer a very short reply. 1.01. What is the ratio of the General Parity Index (GPI) of Egypt, Arab Rep. in 2001 to that in 2012?
Give a very brief answer. 0.95. What is the ratio of the General Parity Index (GPI) in Italy in 2001 to that in 2012?
Provide a succinct answer. 0.99. What is the ratio of the General Parity Index (GPI) of Tajikistan in 2001 to that in 2012?
Your response must be concise. 0.93. What is the ratio of the General Parity Index (GPI) in Belize in 2003 to that in 2004?
Your answer should be compact. 0.98. What is the ratio of the General Parity Index (GPI) of Egypt, Arab Rep. in 2003 to that in 2004?
Provide a succinct answer. 1. What is the ratio of the General Parity Index (GPI) in Italy in 2003 to that in 2004?
Offer a terse response. 0.98. What is the ratio of the General Parity Index (GPI) of Tajikistan in 2003 to that in 2004?
Provide a short and direct response. 0.99. What is the ratio of the General Parity Index (GPI) of Belize in 2003 to that in 2009?
Ensure brevity in your answer.  0.97. What is the ratio of the General Parity Index (GPI) of Egypt, Arab Rep. in 2003 to that in 2009?
Your answer should be compact. 0.95. What is the ratio of the General Parity Index (GPI) in Italy in 2003 to that in 2009?
Provide a short and direct response. 0.98. What is the ratio of the General Parity Index (GPI) of Tajikistan in 2003 to that in 2009?
Provide a succinct answer. 0.93. What is the ratio of the General Parity Index (GPI) of Belize in 2003 to that in 2010?
Give a very brief answer. 0.96. What is the ratio of the General Parity Index (GPI) of Egypt, Arab Rep. in 2003 to that in 2010?
Offer a terse response. 0.97. What is the ratio of the General Parity Index (GPI) in Italy in 2003 to that in 2010?
Offer a very short reply. 0.98. What is the ratio of the General Parity Index (GPI) of Tajikistan in 2003 to that in 2010?
Ensure brevity in your answer.  0.95. What is the ratio of the General Parity Index (GPI) of Belize in 2003 to that in 2011?
Provide a succinct answer. 0.97. What is the ratio of the General Parity Index (GPI) in Egypt, Arab Rep. in 2003 to that in 2011?
Give a very brief answer. 0.95. What is the ratio of the General Parity Index (GPI) of Tajikistan in 2003 to that in 2011?
Your answer should be compact. 0.94. What is the ratio of the General Parity Index (GPI) in Egypt, Arab Rep. in 2003 to that in 2012?
Give a very brief answer. 0.95. What is the ratio of the General Parity Index (GPI) of Italy in 2003 to that in 2012?
Keep it short and to the point. 0.99. What is the ratio of the General Parity Index (GPI) in Tajikistan in 2003 to that in 2012?
Offer a very short reply. 0.93. What is the ratio of the General Parity Index (GPI) of Egypt, Arab Rep. in 2004 to that in 2009?
Offer a terse response. 0.96. What is the ratio of the General Parity Index (GPI) of Italy in 2004 to that in 2009?
Provide a succinct answer. 1. What is the ratio of the General Parity Index (GPI) in Tajikistan in 2004 to that in 2009?
Offer a very short reply. 0.94. What is the ratio of the General Parity Index (GPI) of Belize in 2004 to that in 2010?
Keep it short and to the point. 0.98. What is the ratio of the General Parity Index (GPI) in Egypt, Arab Rep. in 2004 to that in 2010?
Keep it short and to the point. 0.97. What is the ratio of the General Parity Index (GPI) in Tajikistan in 2004 to that in 2010?
Your response must be concise. 0.96. What is the ratio of the General Parity Index (GPI) of Belize in 2004 to that in 2011?
Provide a succinct answer. 0.99. What is the ratio of the General Parity Index (GPI) in Egypt, Arab Rep. in 2004 to that in 2011?
Your answer should be compact. 0.96. What is the ratio of the General Parity Index (GPI) in Italy in 2004 to that in 2011?
Provide a short and direct response. 1.01. What is the ratio of the General Parity Index (GPI) in Tajikistan in 2004 to that in 2011?
Your answer should be compact. 0.95. What is the ratio of the General Parity Index (GPI) in Belize in 2004 to that in 2012?
Your response must be concise. 1.02. What is the ratio of the General Parity Index (GPI) in Egypt, Arab Rep. in 2004 to that in 2012?
Provide a short and direct response. 0.96. What is the ratio of the General Parity Index (GPI) of Italy in 2004 to that in 2012?
Provide a short and direct response. 1.01. What is the ratio of the General Parity Index (GPI) of Tajikistan in 2004 to that in 2012?
Ensure brevity in your answer.  0.94. What is the ratio of the General Parity Index (GPI) of Belize in 2009 to that in 2010?
Your answer should be very brief. 0.99. What is the ratio of the General Parity Index (GPI) in Egypt, Arab Rep. in 2009 to that in 2010?
Offer a very short reply. 1.02. What is the ratio of the General Parity Index (GPI) of Italy in 2009 to that in 2010?
Make the answer very short. 1. What is the ratio of the General Parity Index (GPI) in Tajikistan in 2009 to that in 2010?
Offer a terse response. 1.02. What is the ratio of the General Parity Index (GPI) of Italy in 2009 to that in 2011?
Provide a succinct answer. 1.01. What is the ratio of the General Parity Index (GPI) in Tajikistan in 2009 to that in 2011?
Your response must be concise. 1.01. What is the ratio of the General Parity Index (GPI) of Belize in 2009 to that in 2012?
Ensure brevity in your answer.  1.03. What is the ratio of the General Parity Index (GPI) of Egypt, Arab Rep. in 2009 to that in 2012?
Your answer should be compact. 1. What is the ratio of the General Parity Index (GPI) of Italy in 2009 to that in 2012?
Make the answer very short. 1.01. What is the ratio of the General Parity Index (GPI) of Egypt, Arab Rep. in 2010 to that in 2011?
Provide a succinct answer. 0.98. What is the ratio of the General Parity Index (GPI) of Italy in 2010 to that in 2011?
Offer a very short reply. 1. What is the ratio of the General Parity Index (GPI) in Tajikistan in 2010 to that in 2011?
Make the answer very short. 0.99. What is the ratio of the General Parity Index (GPI) of Belize in 2010 to that in 2012?
Your response must be concise. 1.04. What is the ratio of the General Parity Index (GPI) of Egypt, Arab Rep. in 2010 to that in 2012?
Your answer should be compact. 0.98. What is the ratio of the General Parity Index (GPI) in Tajikistan in 2010 to that in 2012?
Give a very brief answer. 0.97. What is the ratio of the General Parity Index (GPI) in Belize in 2011 to that in 2012?
Give a very brief answer. 1.03. What is the ratio of the General Parity Index (GPI) in Italy in 2011 to that in 2012?
Offer a terse response. 1. What is the ratio of the General Parity Index (GPI) in Tajikistan in 2011 to that in 2012?
Offer a terse response. 0.98. What is the difference between the highest and the second highest General Parity Index (GPI) of Belize?
Your answer should be very brief. 0.01. What is the difference between the highest and the second highest General Parity Index (GPI) of Egypt, Arab Rep.?
Keep it short and to the point. 0. What is the difference between the highest and the second highest General Parity Index (GPI) of Italy?
Provide a succinct answer. 0. What is the difference between the highest and the second highest General Parity Index (GPI) of Tajikistan?
Offer a very short reply. 0.01. What is the difference between the highest and the lowest General Parity Index (GPI) in Belize?
Your answer should be very brief. 0.05. What is the difference between the highest and the lowest General Parity Index (GPI) of Egypt, Arab Rep.?
Provide a succinct answer. 0.06. What is the difference between the highest and the lowest General Parity Index (GPI) of Italy?
Give a very brief answer. 0.03. What is the difference between the highest and the lowest General Parity Index (GPI) in Tajikistan?
Offer a terse response. 0.07. 